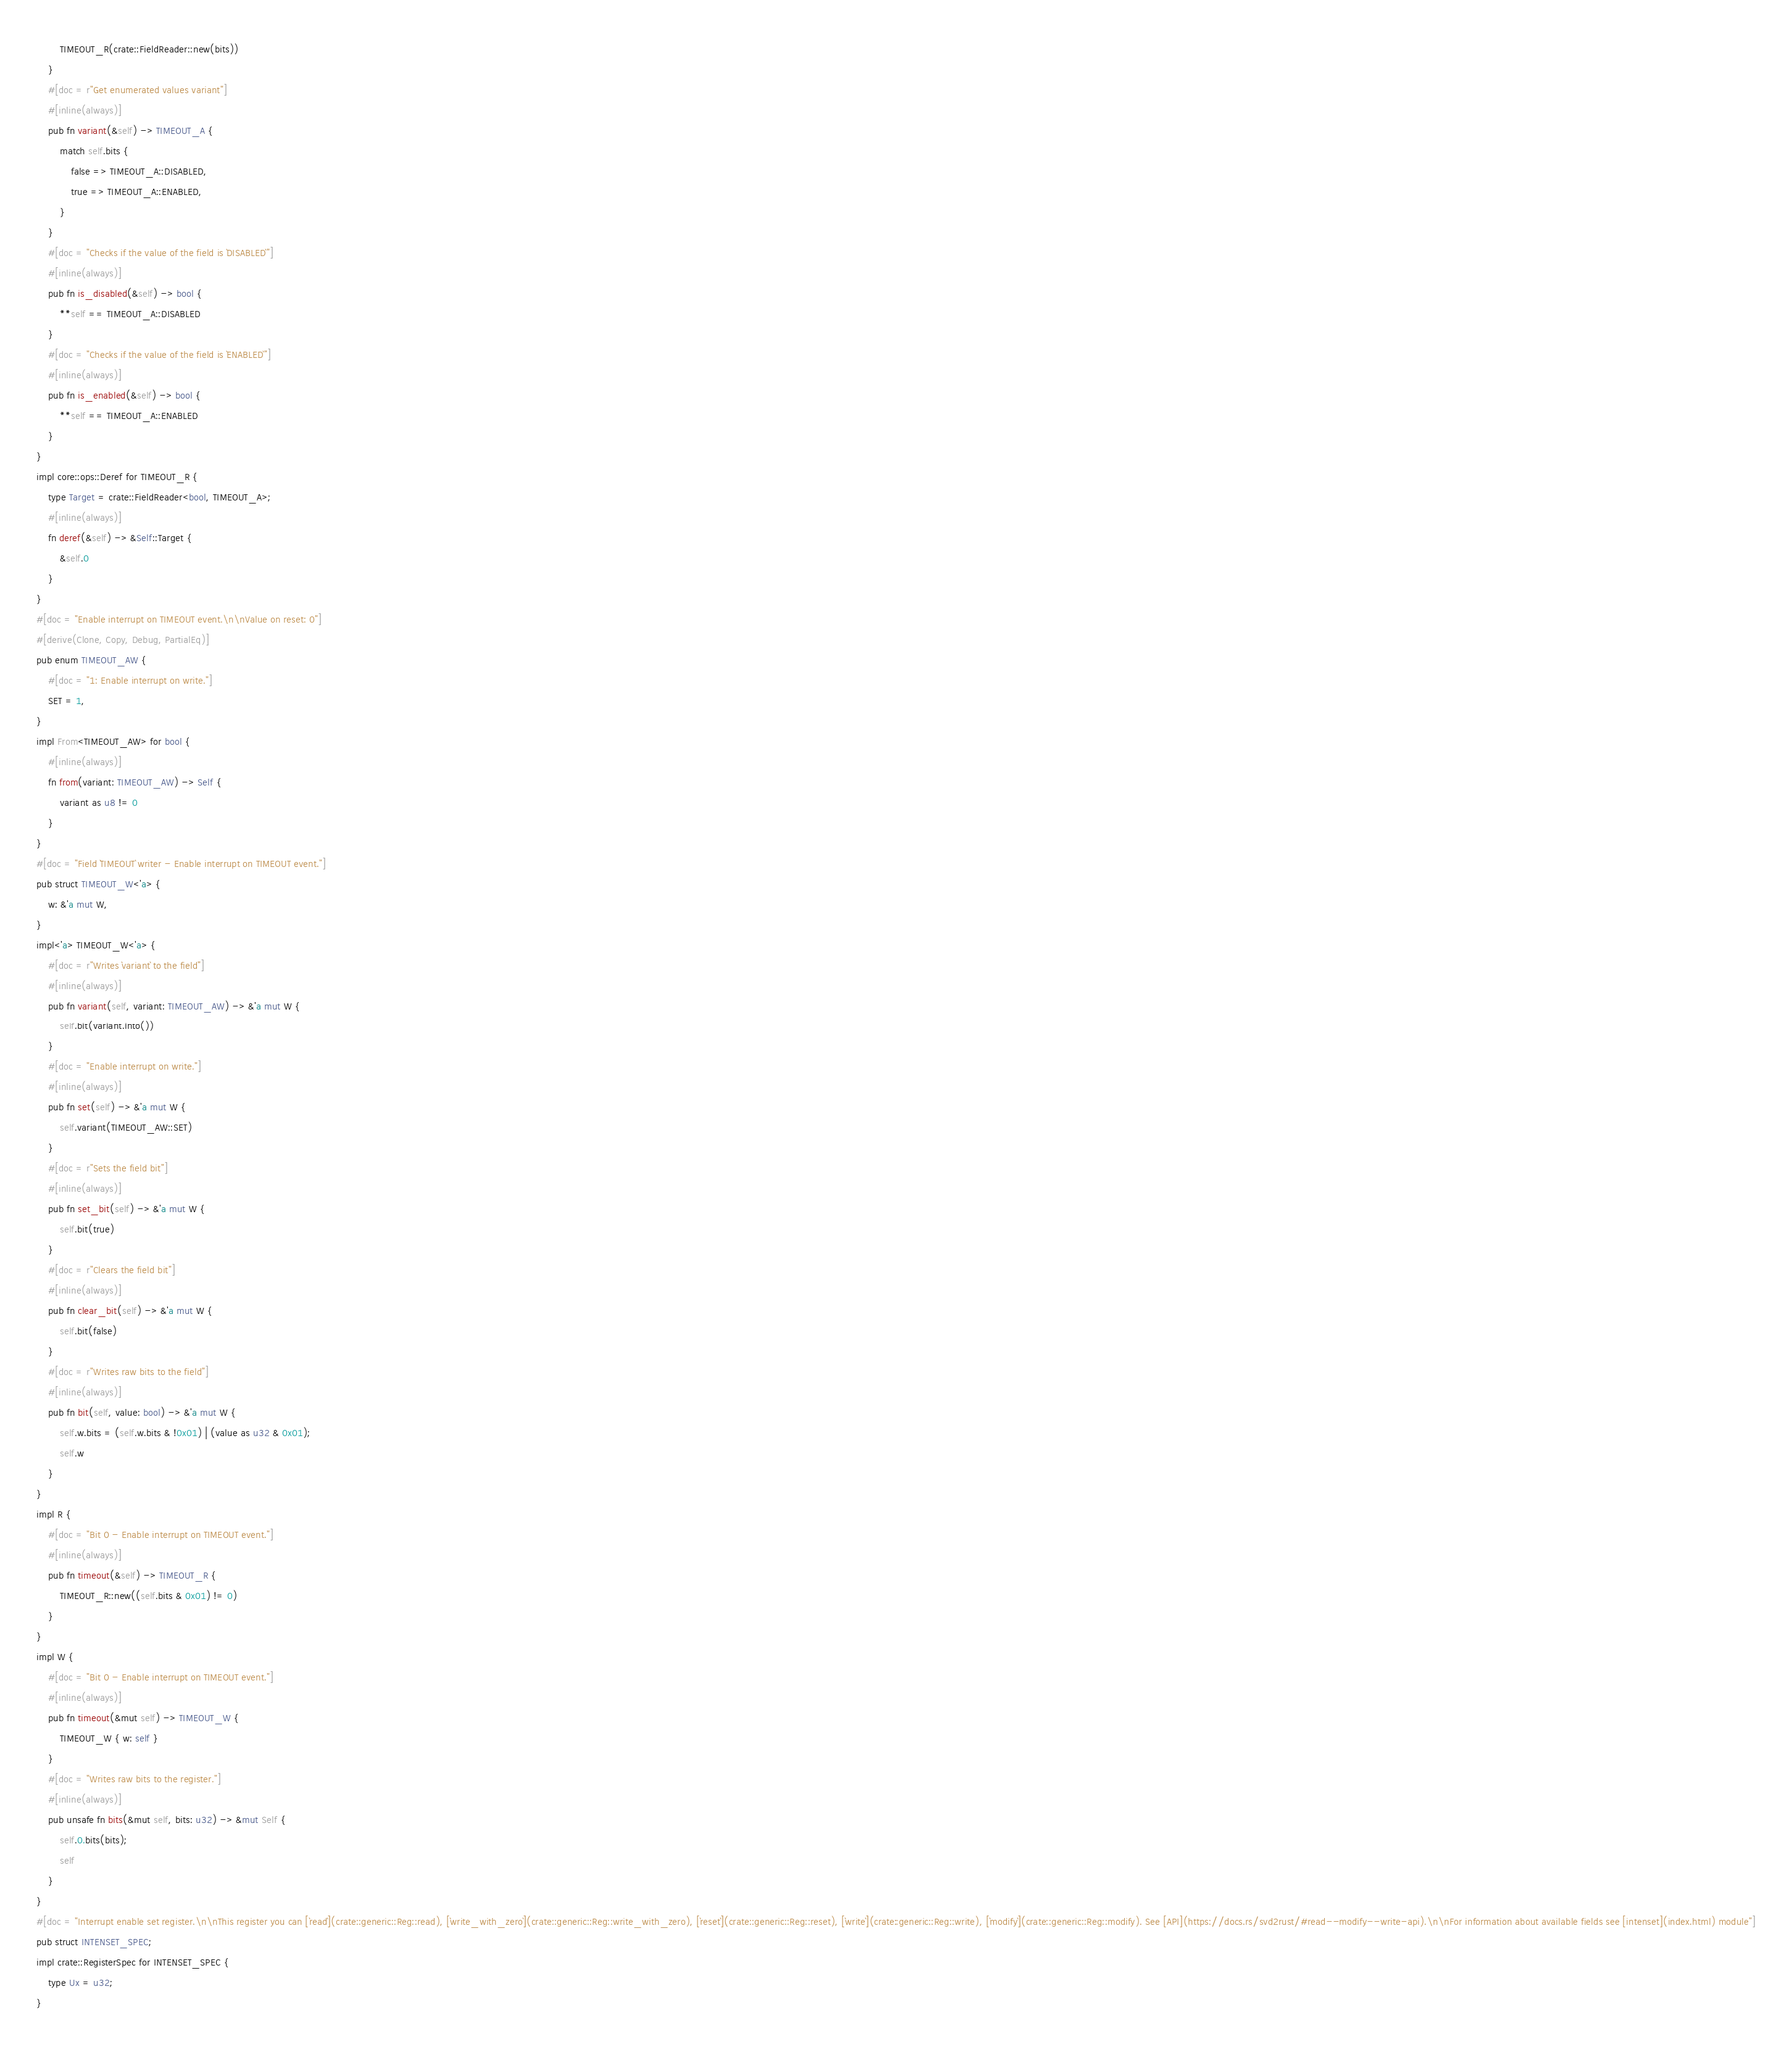Convert code to text. <code><loc_0><loc_0><loc_500><loc_500><_Rust_>        TIMEOUT_R(crate::FieldReader::new(bits))
    }
    #[doc = r"Get enumerated values variant"]
    #[inline(always)]
    pub fn variant(&self) -> TIMEOUT_A {
        match self.bits {
            false => TIMEOUT_A::DISABLED,
            true => TIMEOUT_A::ENABLED,
        }
    }
    #[doc = "Checks if the value of the field is `DISABLED`"]
    #[inline(always)]
    pub fn is_disabled(&self) -> bool {
        **self == TIMEOUT_A::DISABLED
    }
    #[doc = "Checks if the value of the field is `ENABLED`"]
    #[inline(always)]
    pub fn is_enabled(&self) -> bool {
        **self == TIMEOUT_A::ENABLED
    }
}
impl core::ops::Deref for TIMEOUT_R {
    type Target = crate::FieldReader<bool, TIMEOUT_A>;
    #[inline(always)]
    fn deref(&self) -> &Self::Target {
        &self.0
    }
}
#[doc = "Enable interrupt on TIMEOUT event.\n\nValue on reset: 0"]
#[derive(Clone, Copy, Debug, PartialEq)]
pub enum TIMEOUT_AW {
    #[doc = "1: Enable interrupt on write."]
    SET = 1,
}
impl From<TIMEOUT_AW> for bool {
    #[inline(always)]
    fn from(variant: TIMEOUT_AW) -> Self {
        variant as u8 != 0
    }
}
#[doc = "Field `TIMEOUT` writer - Enable interrupt on TIMEOUT event."]
pub struct TIMEOUT_W<'a> {
    w: &'a mut W,
}
impl<'a> TIMEOUT_W<'a> {
    #[doc = r"Writes `variant` to the field"]
    #[inline(always)]
    pub fn variant(self, variant: TIMEOUT_AW) -> &'a mut W {
        self.bit(variant.into())
    }
    #[doc = "Enable interrupt on write."]
    #[inline(always)]
    pub fn set(self) -> &'a mut W {
        self.variant(TIMEOUT_AW::SET)
    }
    #[doc = r"Sets the field bit"]
    #[inline(always)]
    pub fn set_bit(self) -> &'a mut W {
        self.bit(true)
    }
    #[doc = r"Clears the field bit"]
    #[inline(always)]
    pub fn clear_bit(self) -> &'a mut W {
        self.bit(false)
    }
    #[doc = r"Writes raw bits to the field"]
    #[inline(always)]
    pub fn bit(self, value: bool) -> &'a mut W {
        self.w.bits = (self.w.bits & !0x01) | (value as u32 & 0x01);
        self.w
    }
}
impl R {
    #[doc = "Bit 0 - Enable interrupt on TIMEOUT event."]
    #[inline(always)]
    pub fn timeout(&self) -> TIMEOUT_R {
        TIMEOUT_R::new((self.bits & 0x01) != 0)
    }
}
impl W {
    #[doc = "Bit 0 - Enable interrupt on TIMEOUT event."]
    #[inline(always)]
    pub fn timeout(&mut self) -> TIMEOUT_W {
        TIMEOUT_W { w: self }
    }
    #[doc = "Writes raw bits to the register."]
    #[inline(always)]
    pub unsafe fn bits(&mut self, bits: u32) -> &mut Self {
        self.0.bits(bits);
        self
    }
}
#[doc = "Interrupt enable set register.\n\nThis register you can [`read`](crate::generic::Reg::read), [`write_with_zero`](crate::generic::Reg::write_with_zero), [`reset`](crate::generic::Reg::reset), [`write`](crate::generic::Reg::write), [`modify`](crate::generic::Reg::modify). See [API](https://docs.rs/svd2rust/#read--modify--write-api).\n\nFor information about available fields see [intenset](index.html) module"]
pub struct INTENSET_SPEC;
impl crate::RegisterSpec for INTENSET_SPEC {
    type Ux = u32;
}</code> 